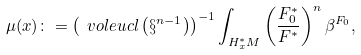Convert formula to latex. <formula><loc_0><loc_0><loc_500><loc_500>\mu ( x ) \colon = \left ( \ v o l e u c l \left ( \S ^ { n - 1 } \right ) \right ) ^ { - 1 } \int _ { H _ { x } ^ { \ast } M } \left ( \frac { F _ { 0 } ^ { \ast } } { F ^ { \ast } } \right ) ^ { n } \beta ^ { F _ { 0 } } ,</formula> 